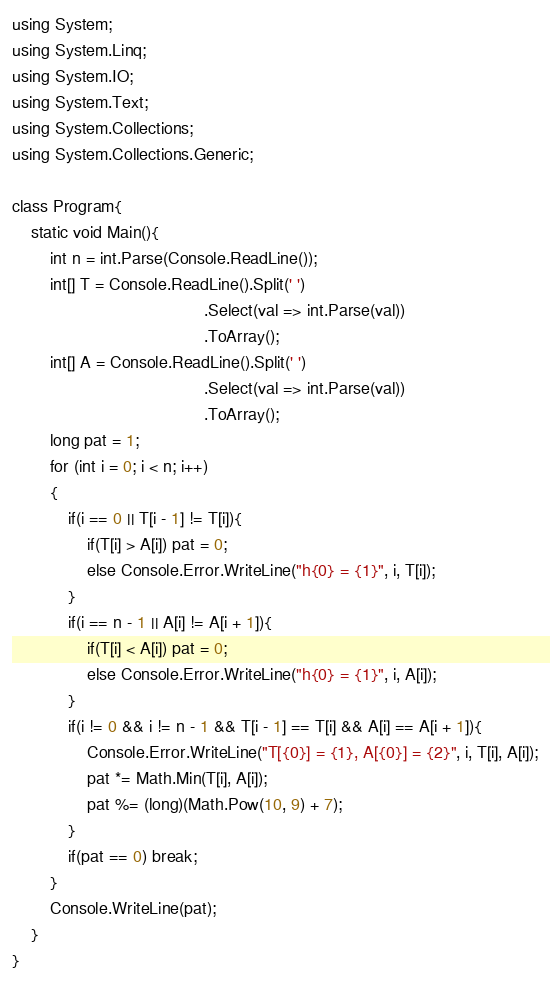Convert code to text. <code><loc_0><loc_0><loc_500><loc_500><_C#_>using System;
using System.Linq;
using System.IO;
using System.Text;
using System.Collections;
using System.Collections.Generic;
 
class Program{
    static void Main(){
        int n = int.Parse(Console.ReadLine());
        int[] T = Console.ReadLine().Split(' ')
                                         .Select(val => int.Parse(val))
                                         .ToArray();
        int[] A = Console.ReadLine().Split(' ')
                                         .Select(val => int.Parse(val))
                                         .ToArray();
        long pat = 1;
        for (int i = 0; i < n; i++)
        {
            if(i == 0 || T[i - 1] != T[i]){
                if(T[i] > A[i]) pat = 0;
                else Console.Error.WriteLine("h{0} = {1}", i, T[i]);
            }
            if(i == n - 1 || A[i] != A[i + 1]){
                if(T[i] < A[i]) pat = 0;
                else Console.Error.WriteLine("h{0} = {1}", i, A[i]);
            }
            if(i != 0 && i != n - 1 && T[i - 1] == T[i] && A[i] == A[i + 1]){
                Console.Error.WriteLine("T[{0}] = {1}, A[{0}] = {2}", i, T[i], A[i]);
                pat *= Math.Min(T[i], A[i]);
                pat %= (long)(Math.Pow(10, 9) + 7);
            }
            if(pat == 0) break;
        }
        Console.WriteLine(pat);
    }
}
</code> 